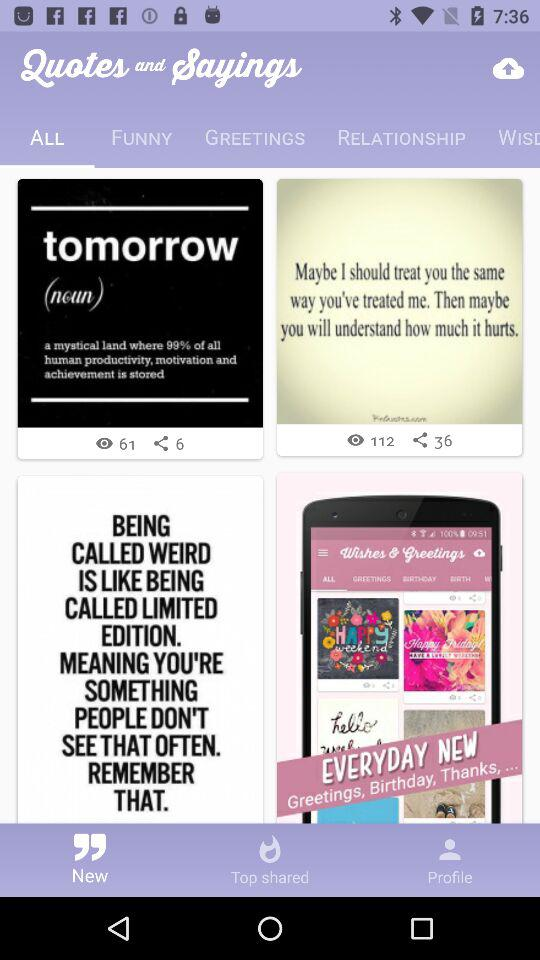What is the name of the application? The name of the application is "Quotes and Sayings". 